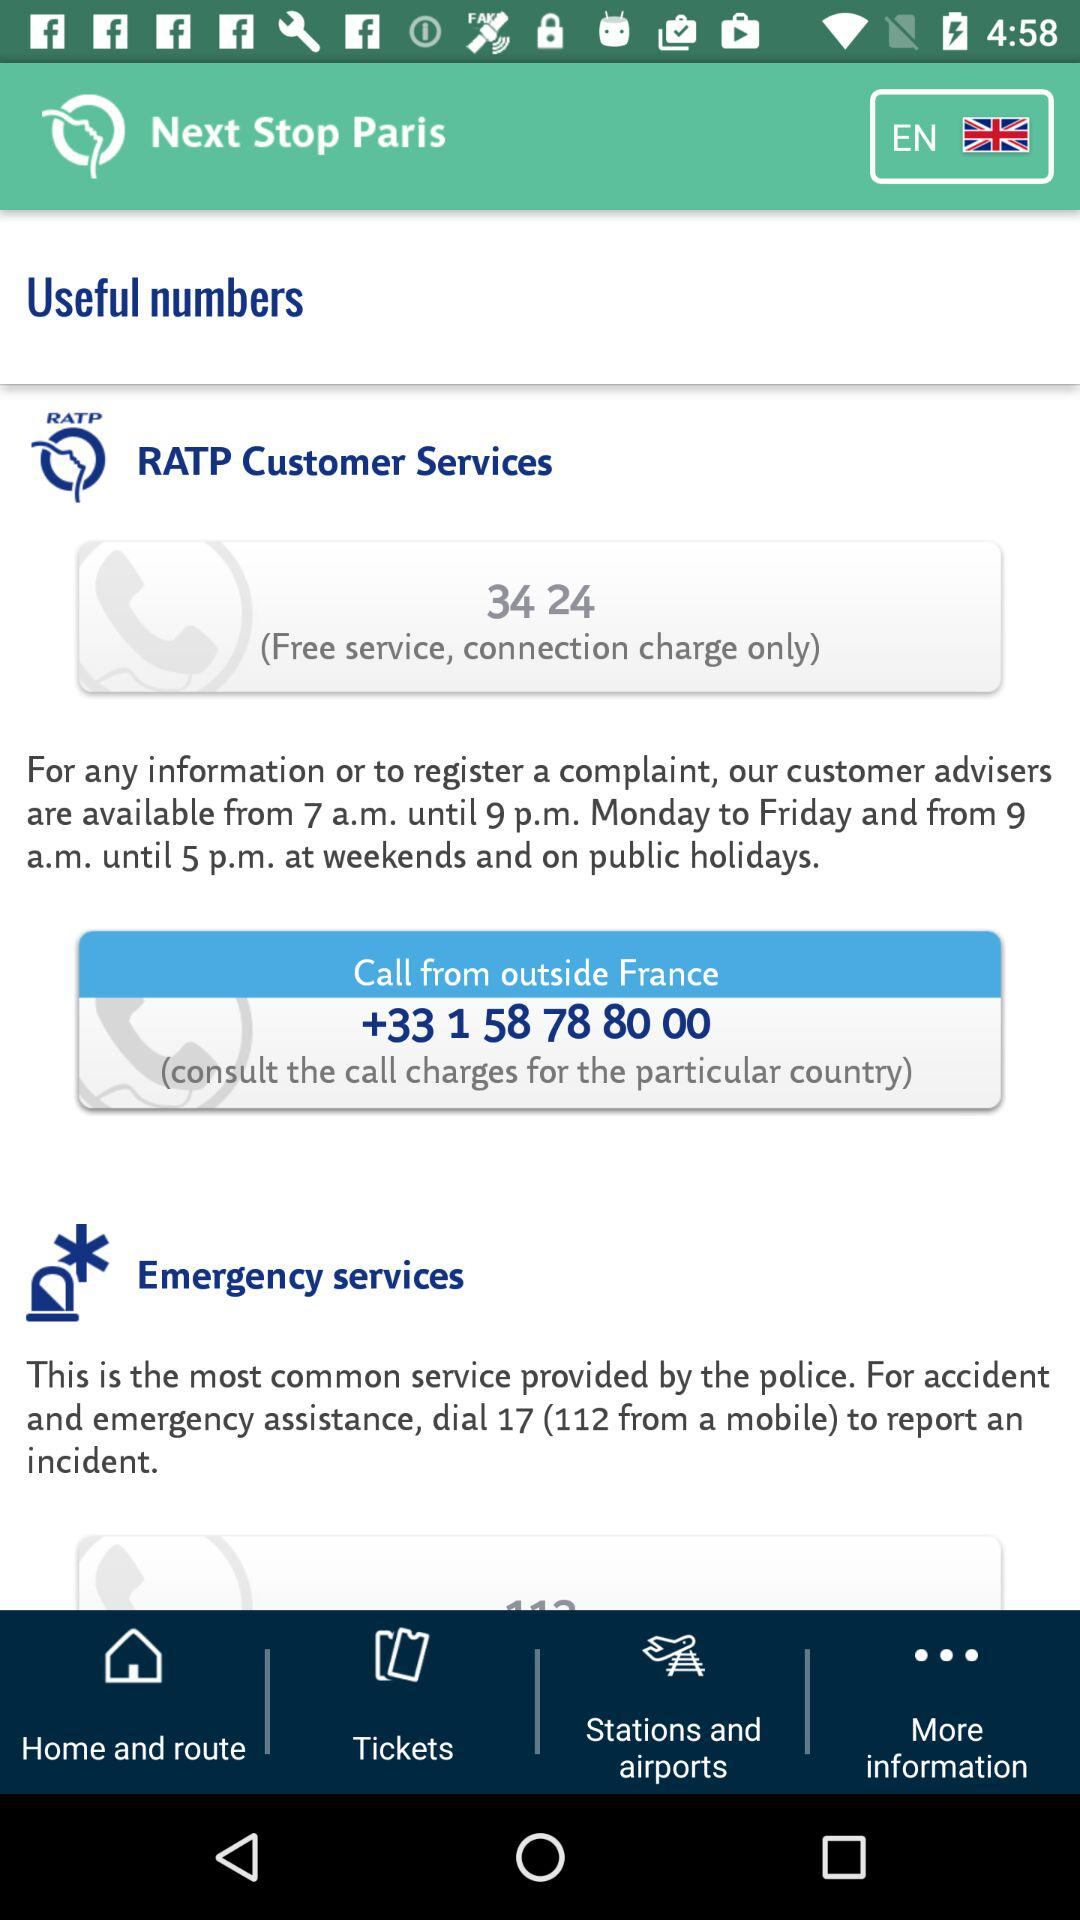What's the dial and mobile number for accident and emergency assistance? The dial and mobile numbers for accident and emergency assistance are 17 and 112, respectively. 